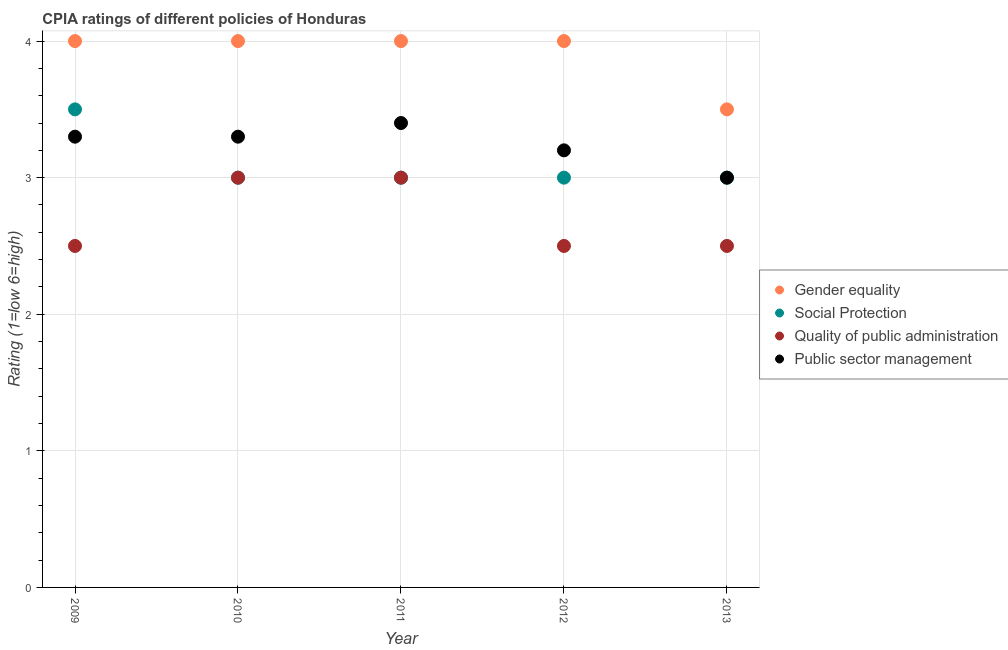Is the number of dotlines equal to the number of legend labels?
Provide a short and direct response. Yes. What is the cpia rating of quality of public administration in 2010?
Offer a terse response. 3. Across all years, what is the minimum cpia rating of social protection?
Your response must be concise. 3. In which year was the cpia rating of quality of public administration maximum?
Ensure brevity in your answer.  2010. What is the difference between the cpia rating of gender equality in 2010 and that in 2013?
Your answer should be compact. 0.5. What is the difference between the cpia rating of gender equality in 2013 and the cpia rating of quality of public administration in 2012?
Your answer should be very brief. 1. In the year 2009, what is the difference between the cpia rating of social protection and cpia rating of quality of public administration?
Give a very brief answer. 1. What is the ratio of the cpia rating of public sector management in 2011 to that in 2012?
Offer a terse response. 1.06. Is the difference between the cpia rating of social protection in 2009 and 2012 greater than the difference between the cpia rating of quality of public administration in 2009 and 2012?
Your response must be concise. Yes. What is the difference between the highest and the second highest cpia rating of social protection?
Your response must be concise. 0.5. What is the difference between the highest and the lowest cpia rating of quality of public administration?
Give a very brief answer. 0.5. Is the sum of the cpia rating of social protection in 2009 and 2011 greater than the maximum cpia rating of gender equality across all years?
Your answer should be compact. Yes. Is it the case that in every year, the sum of the cpia rating of quality of public administration and cpia rating of public sector management is greater than the sum of cpia rating of gender equality and cpia rating of social protection?
Ensure brevity in your answer.  Yes. Does the cpia rating of gender equality monotonically increase over the years?
Provide a short and direct response. No. Is the cpia rating of quality of public administration strictly less than the cpia rating of gender equality over the years?
Provide a short and direct response. Yes. How many years are there in the graph?
Offer a very short reply. 5. Are the values on the major ticks of Y-axis written in scientific E-notation?
Offer a very short reply. No. What is the title of the graph?
Your response must be concise. CPIA ratings of different policies of Honduras. What is the label or title of the X-axis?
Make the answer very short. Year. What is the Rating (1=low 6=high) in Quality of public administration in 2009?
Ensure brevity in your answer.  2.5. What is the Rating (1=low 6=high) in Quality of public administration in 2010?
Your response must be concise. 3. What is the Rating (1=low 6=high) of Public sector management in 2010?
Offer a very short reply. 3.3. What is the Rating (1=low 6=high) of Gender equality in 2011?
Offer a very short reply. 4. What is the Rating (1=low 6=high) in Quality of public administration in 2011?
Your answer should be very brief. 3. What is the Rating (1=low 6=high) in Gender equality in 2012?
Provide a short and direct response. 4. What is the Rating (1=low 6=high) in Social Protection in 2012?
Your response must be concise. 3. What is the Rating (1=low 6=high) of Quality of public administration in 2012?
Keep it short and to the point. 2.5. What is the Rating (1=low 6=high) in Social Protection in 2013?
Give a very brief answer. 3. Across all years, what is the maximum Rating (1=low 6=high) of Gender equality?
Give a very brief answer. 4. Across all years, what is the maximum Rating (1=low 6=high) of Social Protection?
Provide a short and direct response. 3.5. What is the total Rating (1=low 6=high) in Social Protection in the graph?
Give a very brief answer. 15.5. What is the total Rating (1=low 6=high) in Public sector management in the graph?
Ensure brevity in your answer.  16.2. What is the difference between the Rating (1=low 6=high) of Gender equality in 2009 and that in 2010?
Give a very brief answer. 0. What is the difference between the Rating (1=low 6=high) in Quality of public administration in 2009 and that in 2010?
Give a very brief answer. -0.5. What is the difference between the Rating (1=low 6=high) in Quality of public administration in 2009 and that in 2012?
Provide a succinct answer. 0. What is the difference between the Rating (1=low 6=high) in Public sector management in 2009 and that in 2012?
Your answer should be compact. 0.1. What is the difference between the Rating (1=low 6=high) of Social Protection in 2009 and that in 2013?
Provide a succinct answer. 0.5. What is the difference between the Rating (1=low 6=high) in Quality of public administration in 2009 and that in 2013?
Keep it short and to the point. 0. What is the difference between the Rating (1=low 6=high) of Gender equality in 2010 and that in 2011?
Ensure brevity in your answer.  0. What is the difference between the Rating (1=low 6=high) of Social Protection in 2010 and that in 2011?
Your response must be concise. 0. What is the difference between the Rating (1=low 6=high) of Quality of public administration in 2010 and that in 2011?
Offer a very short reply. 0. What is the difference between the Rating (1=low 6=high) in Public sector management in 2010 and that in 2011?
Make the answer very short. -0.1. What is the difference between the Rating (1=low 6=high) in Gender equality in 2010 and that in 2012?
Your answer should be very brief. 0. What is the difference between the Rating (1=low 6=high) in Social Protection in 2010 and that in 2012?
Your response must be concise. 0. What is the difference between the Rating (1=low 6=high) in Public sector management in 2010 and that in 2012?
Offer a terse response. 0.1. What is the difference between the Rating (1=low 6=high) in Gender equality in 2010 and that in 2013?
Your response must be concise. 0.5. What is the difference between the Rating (1=low 6=high) in Public sector management in 2010 and that in 2013?
Offer a very short reply. 0.3. What is the difference between the Rating (1=low 6=high) of Social Protection in 2011 and that in 2012?
Provide a short and direct response. 0. What is the difference between the Rating (1=low 6=high) in Social Protection in 2011 and that in 2013?
Provide a succinct answer. 0. What is the difference between the Rating (1=low 6=high) in Quality of public administration in 2011 and that in 2013?
Ensure brevity in your answer.  0.5. What is the difference between the Rating (1=low 6=high) in Public sector management in 2011 and that in 2013?
Offer a very short reply. 0.4. What is the difference between the Rating (1=low 6=high) of Quality of public administration in 2012 and that in 2013?
Make the answer very short. 0. What is the difference between the Rating (1=low 6=high) of Public sector management in 2012 and that in 2013?
Provide a short and direct response. 0.2. What is the difference between the Rating (1=low 6=high) of Gender equality in 2009 and the Rating (1=low 6=high) of Social Protection in 2010?
Make the answer very short. 1. What is the difference between the Rating (1=low 6=high) of Gender equality in 2009 and the Rating (1=low 6=high) of Public sector management in 2010?
Give a very brief answer. 0.7. What is the difference between the Rating (1=low 6=high) of Social Protection in 2009 and the Rating (1=low 6=high) of Quality of public administration in 2010?
Ensure brevity in your answer.  0.5. What is the difference between the Rating (1=low 6=high) of Social Protection in 2009 and the Rating (1=low 6=high) of Public sector management in 2010?
Provide a succinct answer. 0.2. What is the difference between the Rating (1=low 6=high) of Quality of public administration in 2009 and the Rating (1=low 6=high) of Public sector management in 2010?
Provide a short and direct response. -0.8. What is the difference between the Rating (1=low 6=high) of Gender equality in 2009 and the Rating (1=low 6=high) of Social Protection in 2011?
Make the answer very short. 1. What is the difference between the Rating (1=low 6=high) in Gender equality in 2009 and the Rating (1=low 6=high) in Quality of public administration in 2011?
Make the answer very short. 1. What is the difference between the Rating (1=low 6=high) of Gender equality in 2009 and the Rating (1=low 6=high) of Public sector management in 2011?
Give a very brief answer. 0.6. What is the difference between the Rating (1=low 6=high) of Social Protection in 2009 and the Rating (1=low 6=high) of Quality of public administration in 2011?
Provide a short and direct response. 0.5. What is the difference between the Rating (1=low 6=high) in Quality of public administration in 2009 and the Rating (1=low 6=high) in Public sector management in 2011?
Ensure brevity in your answer.  -0.9. What is the difference between the Rating (1=low 6=high) of Gender equality in 2009 and the Rating (1=low 6=high) of Social Protection in 2012?
Your answer should be very brief. 1. What is the difference between the Rating (1=low 6=high) in Social Protection in 2009 and the Rating (1=low 6=high) in Quality of public administration in 2012?
Offer a terse response. 1. What is the difference between the Rating (1=low 6=high) of Social Protection in 2009 and the Rating (1=low 6=high) of Public sector management in 2012?
Your answer should be compact. 0.3. What is the difference between the Rating (1=low 6=high) in Social Protection in 2009 and the Rating (1=low 6=high) in Quality of public administration in 2013?
Your answer should be compact. 1. What is the difference between the Rating (1=low 6=high) in Social Protection in 2009 and the Rating (1=low 6=high) in Public sector management in 2013?
Offer a terse response. 0.5. What is the difference between the Rating (1=low 6=high) in Gender equality in 2010 and the Rating (1=low 6=high) in Social Protection in 2011?
Your answer should be very brief. 1. What is the difference between the Rating (1=low 6=high) of Gender equality in 2010 and the Rating (1=low 6=high) of Quality of public administration in 2011?
Your answer should be compact. 1. What is the difference between the Rating (1=low 6=high) of Gender equality in 2010 and the Rating (1=low 6=high) of Public sector management in 2011?
Your answer should be compact. 0.6. What is the difference between the Rating (1=low 6=high) in Social Protection in 2010 and the Rating (1=low 6=high) in Public sector management in 2011?
Offer a terse response. -0.4. What is the difference between the Rating (1=low 6=high) in Gender equality in 2010 and the Rating (1=low 6=high) in Public sector management in 2012?
Provide a short and direct response. 0.8. What is the difference between the Rating (1=low 6=high) of Social Protection in 2010 and the Rating (1=low 6=high) of Quality of public administration in 2012?
Make the answer very short. 0.5. What is the difference between the Rating (1=low 6=high) of Gender equality in 2010 and the Rating (1=low 6=high) of Social Protection in 2013?
Provide a short and direct response. 1. What is the difference between the Rating (1=low 6=high) of Gender equality in 2010 and the Rating (1=low 6=high) of Public sector management in 2013?
Your response must be concise. 1. What is the difference between the Rating (1=low 6=high) of Social Protection in 2010 and the Rating (1=low 6=high) of Public sector management in 2013?
Ensure brevity in your answer.  0. What is the difference between the Rating (1=low 6=high) in Gender equality in 2011 and the Rating (1=low 6=high) in Public sector management in 2012?
Your answer should be compact. 0.8. What is the difference between the Rating (1=low 6=high) in Quality of public administration in 2011 and the Rating (1=low 6=high) in Public sector management in 2012?
Offer a terse response. -0.2. What is the difference between the Rating (1=low 6=high) of Gender equality in 2011 and the Rating (1=low 6=high) of Public sector management in 2013?
Offer a very short reply. 1. What is the difference between the Rating (1=low 6=high) of Quality of public administration in 2011 and the Rating (1=low 6=high) of Public sector management in 2013?
Ensure brevity in your answer.  0. What is the difference between the Rating (1=low 6=high) of Gender equality in 2012 and the Rating (1=low 6=high) of Social Protection in 2013?
Offer a terse response. 1. What is the difference between the Rating (1=low 6=high) of Gender equality in 2012 and the Rating (1=low 6=high) of Quality of public administration in 2013?
Your answer should be compact. 1.5. What is the difference between the Rating (1=low 6=high) in Gender equality in 2012 and the Rating (1=low 6=high) in Public sector management in 2013?
Provide a short and direct response. 1. What is the difference between the Rating (1=low 6=high) of Social Protection in 2012 and the Rating (1=low 6=high) of Public sector management in 2013?
Offer a very short reply. 0. What is the average Rating (1=low 6=high) of Public sector management per year?
Ensure brevity in your answer.  3.24. In the year 2009, what is the difference between the Rating (1=low 6=high) in Gender equality and Rating (1=low 6=high) in Social Protection?
Your answer should be compact. 0.5. In the year 2009, what is the difference between the Rating (1=low 6=high) of Gender equality and Rating (1=low 6=high) of Quality of public administration?
Offer a very short reply. 1.5. In the year 2009, what is the difference between the Rating (1=low 6=high) of Gender equality and Rating (1=low 6=high) of Public sector management?
Provide a short and direct response. 0.7. In the year 2009, what is the difference between the Rating (1=low 6=high) in Social Protection and Rating (1=low 6=high) in Public sector management?
Your response must be concise. 0.2. In the year 2009, what is the difference between the Rating (1=low 6=high) in Quality of public administration and Rating (1=low 6=high) in Public sector management?
Make the answer very short. -0.8. In the year 2010, what is the difference between the Rating (1=low 6=high) of Gender equality and Rating (1=low 6=high) of Public sector management?
Provide a succinct answer. 0.7. In the year 2010, what is the difference between the Rating (1=low 6=high) of Social Protection and Rating (1=low 6=high) of Public sector management?
Offer a very short reply. -0.3. In the year 2011, what is the difference between the Rating (1=low 6=high) of Gender equality and Rating (1=low 6=high) of Social Protection?
Provide a short and direct response. 1. In the year 2011, what is the difference between the Rating (1=low 6=high) in Gender equality and Rating (1=low 6=high) in Public sector management?
Your response must be concise. 0.6. In the year 2012, what is the difference between the Rating (1=low 6=high) of Gender equality and Rating (1=low 6=high) of Social Protection?
Offer a very short reply. 1. In the year 2012, what is the difference between the Rating (1=low 6=high) in Gender equality and Rating (1=low 6=high) in Quality of public administration?
Offer a terse response. 1.5. In the year 2012, what is the difference between the Rating (1=low 6=high) of Quality of public administration and Rating (1=low 6=high) of Public sector management?
Your answer should be compact. -0.7. In the year 2013, what is the difference between the Rating (1=low 6=high) of Gender equality and Rating (1=low 6=high) of Social Protection?
Make the answer very short. 0.5. In the year 2013, what is the difference between the Rating (1=low 6=high) in Social Protection and Rating (1=low 6=high) in Quality of public administration?
Keep it short and to the point. 0.5. In the year 2013, what is the difference between the Rating (1=low 6=high) in Social Protection and Rating (1=low 6=high) in Public sector management?
Give a very brief answer. 0. What is the ratio of the Rating (1=low 6=high) in Social Protection in 2009 to that in 2010?
Your answer should be compact. 1.17. What is the ratio of the Rating (1=low 6=high) of Public sector management in 2009 to that in 2010?
Offer a very short reply. 1. What is the ratio of the Rating (1=low 6=high) in Social Protection in 2009 to that in 2011?
Provide a succinct answer. 1.17. What is the ratio of the Rating (1=low 6=high) in Quality of public administration in 2009 to that in 2011?
Provide a short and direct response. 0.83. What is the ratio of the Rating (1=low 6=high) in Public sector management in 2009 to that in 2011?
Your answer should be very brief. 0.97. What is the ratio of the Rating (1=low 6=high) of Gender equality in 2009 to that in 2012?
Offer a terse response. 1. What is the ratio of the Rating (1=low 6=high) of Social Protection in 2009 to that in 2012?
Your response must be concise. 1.17. What is the ratio of the Rating (1=low 6=high) of Quality of public administration in 2009 to that in 2012?
Your answer should be compact. 1. What is the ratio of the Rating (1=low 6=high) of Public sector management in 2009 to that in 2012?
Offer a very short reply. 1.03. What is the ratio of the Rating (1=low 6=high) of Social Protection in 2009 to that in 2013?
Ensure brevity in your answer.  1.17. What is the ratio of the Rating (1=low 6=high) of Public sector management in 2009 to that in 2013?
Your response must be concise. 1.1. What is the ratio of the Rating (1=low 6=high) of Social Protection in 2010 to that in 2011?
Offer a terse response. 1. What is the ratio of the Rating (1=low 6=high) of Public sector management in 2010 to that in 2011?
Make the answer very short. 0.97. What is the ratio of the Rating (1=low 6=high) of Gender equality in 2010 to that in 2012?
Your answer should be very brief. 1. What is the ratio of the Rating (1=low 6=high) in Social Protection in 2010 to that in 2012?
Give a very brief answer. 1. What is the ratio of the Rating (1=low 6=high) in Public sector management in 2010 to that in 2012?
Ensure brevity in your answer.  1.03. What is the ratio of the Rating (1=low 6=high) of Gender equality in 2010 to that in 2013?
Your answer should be compact. 1.14. What is the ratio of the Rating (1=low 6=high) in Social Protection in 2010 to that in 2013?
Your answer should be very brief. 1. What is the ratio of the Rating (1=low 6=high) in Quality of public administration in 2010 to that in 2013?
Offer a terse response. 1.2. What is the ratio of the Rating (1=low 6=high) of Social Protection in 2011 to that in 2012?
Offer a terse response. 1. What is the ratio of the Rating (1=low 6=high) in Quality of public administration in 2011 to that in 2012?
Keep it short and to the point. 1.2. What is the ratio of the Rating (1=low 6=high) of Public sector management in 2011 to that in 2012?
Provide a succinct answer. 1.06. What is the ratio of the Rating (1=low 6=high) of Social Protection in 2011 to that in 2013?
Make the answer very short. 1. What is the ratio of the Rating (1=low 6=high) in Quality of public administration in 2011 to that in 2013?
Offer a very short reply. 1.2. What is the ratio of the Rating (1=low 6=high) in Public sector management in 2011 to that in 2013?
Your response must be concise. 1.13. What is the ratio of the Rating (1=low 6=high) of Social Protection in 2012 to that in 2013?
Your answer should be compact. 1. What is the ratio of the Rating (1=low 6=high) in Public sector management in 2012 to that in 2013?
Your response must be concise. 1.07. What is the difference between the highest and the second highest Rating (1=low 6=high) in Social Protection?
Offer a terse response. 0.5. What is the difference between the highest and the lowest Rating (1=low 6=high) in Gender equality?
Your response must be concise. 0.5. What is the difference between the highest and the lowest Rating (1=low 6=high) in Social Protection?
Give a very brief answer. 0.5. What is the difference between the highest and the lowest Rating (1=low 6=high) of Public sector management?
Provide a short and direct response. 0.4. 